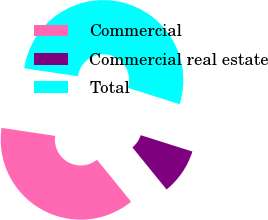Convert chart. <chart><loc_0><loc_0><loc_500><loc_500><pie_chart><fcel>Commercial<fcel>Commercial real estate<fcel>Total<nl><fcel>38.22%<fcel>9.26%<fcel>52.52%<nl></chart> 